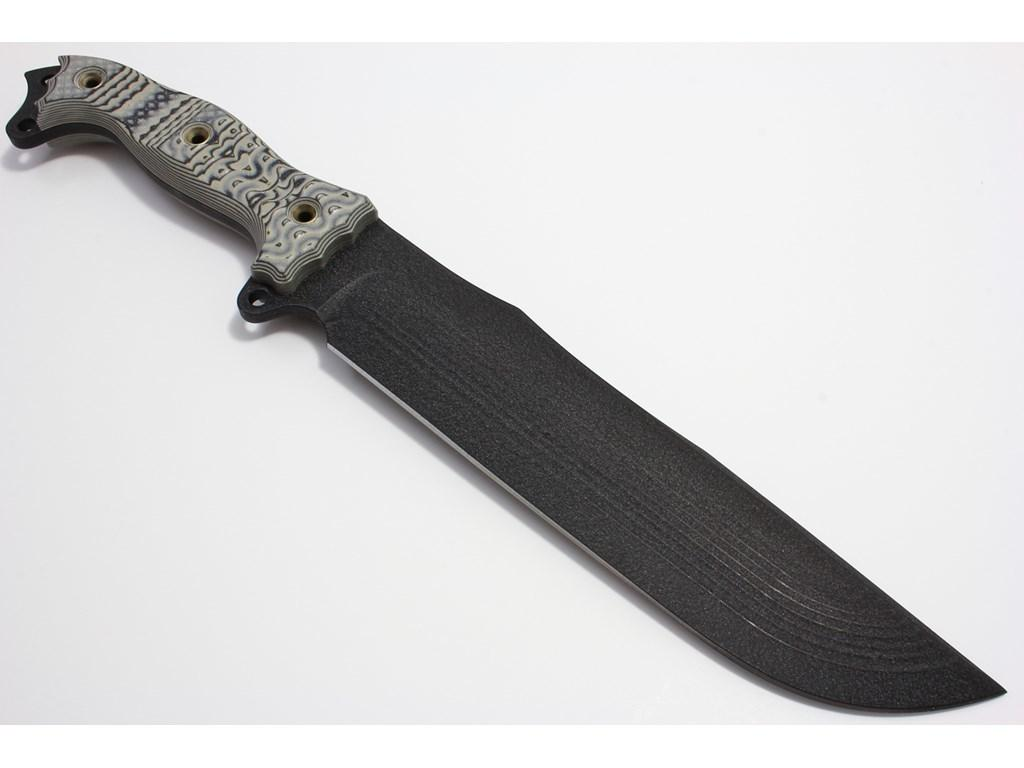What object is located in the center of the image? There is a knife in the center of the image. What type of hat is the person wearing in the image? There is no person or hat present in the image; it only features a knife. What is the weather like in the image, considering it's summer? The image does not provide any information about the weather or season, as it only features a knife. 